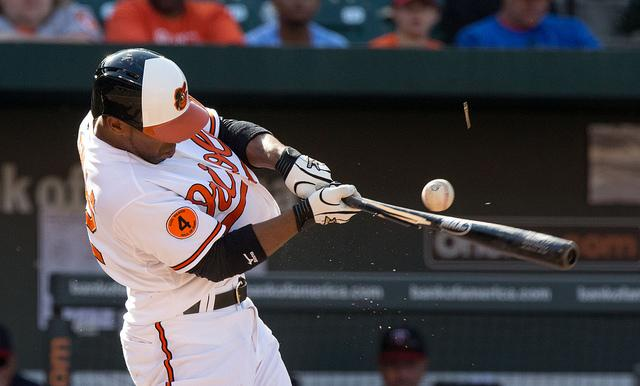Who got this ball to this place?

Choices:
A) catcher
B) pitcher
C) outfielder
D) coach pitcher 